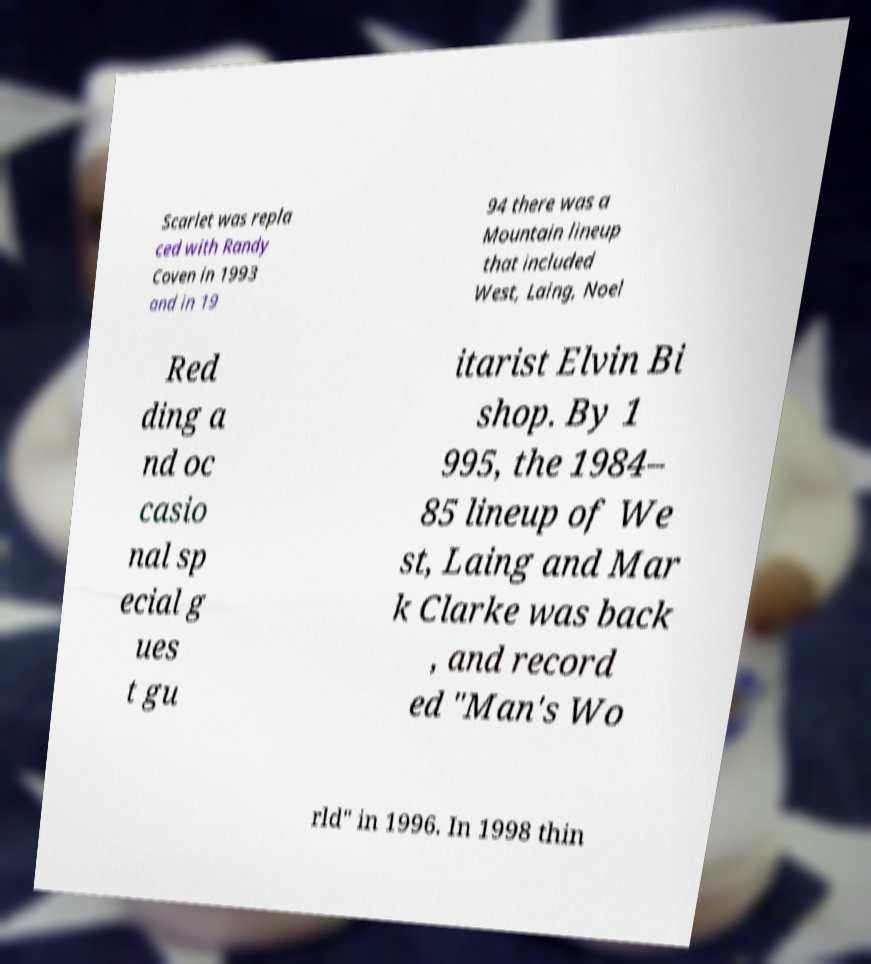For documentation purposes, I need the text within this image transcribed. Could you provide that? Scarlet was repla ced with Randy Coven in 1993 and in 19 94 there was a Mountain lineup that included West, Laing, Noel Red ding a nd oc casio nal sp ecial g ues t gu itarist Elvin Bi shop. By 1 995, the 1984– 85 lineup of We st, Laing and Mar k Clarke was back , and record ed "Man's Wo rld" in 1996. In 1998 thin 